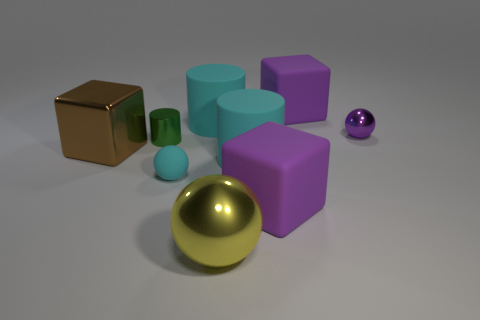Subtract all cyan rubber cylinders. How many cylinders are left? 1 Subtract all cyan cylinders. How many cylinders are left? 1 Add 1 purple shiny things. How many objects exist? 10 Subtract all green cubes. How many purple spheres are left? 1 Subtract all balls. How many objects are left? 6 Add 3 shiny things. How many shiny things are left? 7 Add 1 tiny metal cylinders. How many tiny metal cylinders exist? 2 Subtract 1 cyan spheres. How many objects are left? 8 Subtract 2 cylinders. How many cylinders are left? 1 Subtract all cyan cylinders. Subtract all yellow blocks. How many cylinders are left? 1 